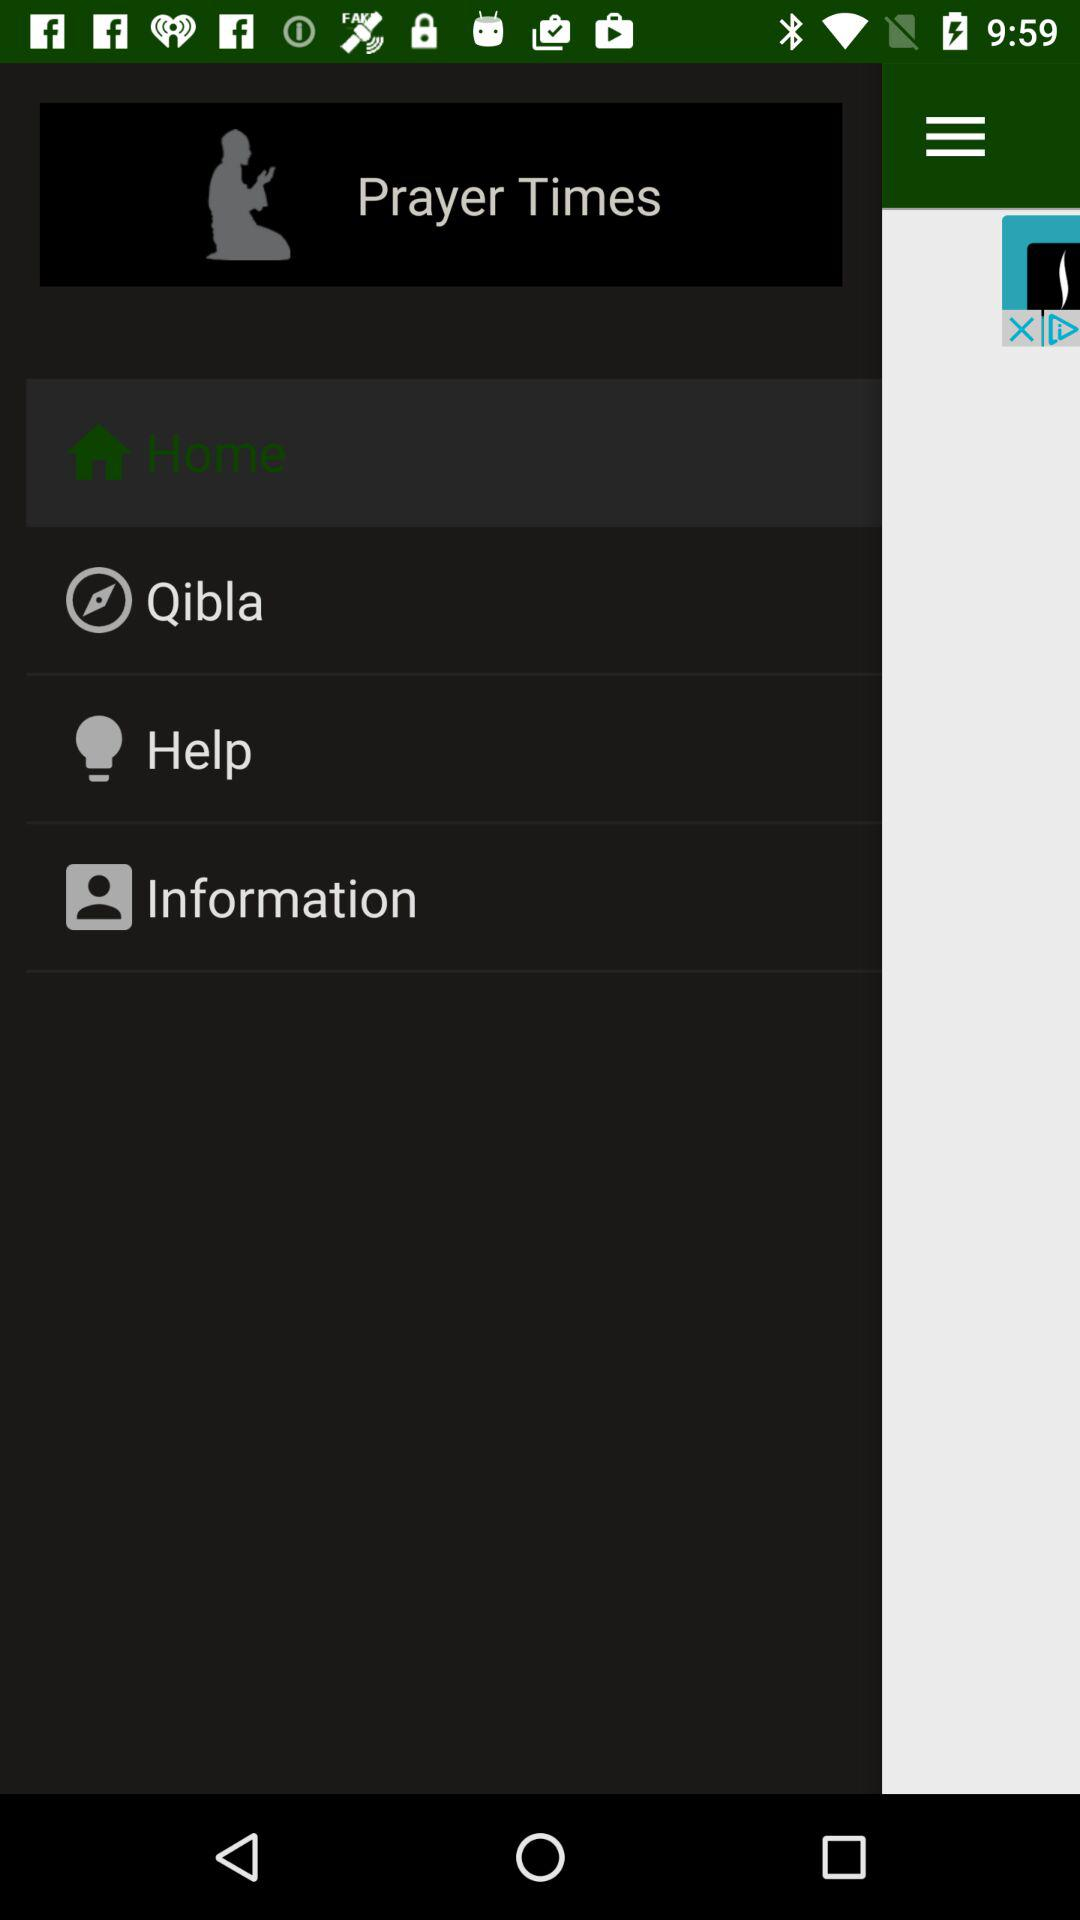Which item is selected? The selected item is "Home". 